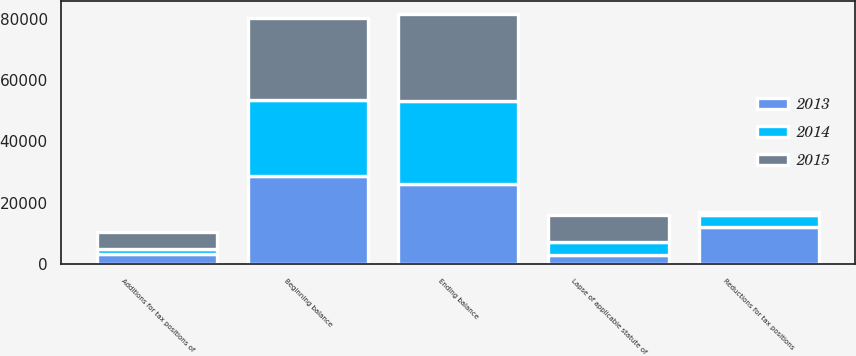Convert chart. <chart><loc_0><loc_0><loc_500><loc_500><stacked_bar_chart><ecel><fcel>Beginning balance<fcel>Additions for tax positions of<fcel>Reductions for tax positions<fcel>Lapse of applicable statute of<fcel>Ending balance<nl><fcel>2013<fcel>28567<fcel>3299<fcel>12206<fcel>3080<fcel>26140<nl><fcel>2015<fcel>26924<fcel>5571<fcel>1008<fcel>8934<fcel>28567<nl><fcel>2014<fcel>24865<fcel>1639<fcel>3675<fcel>3986<fcel>26924<nl></chart> 